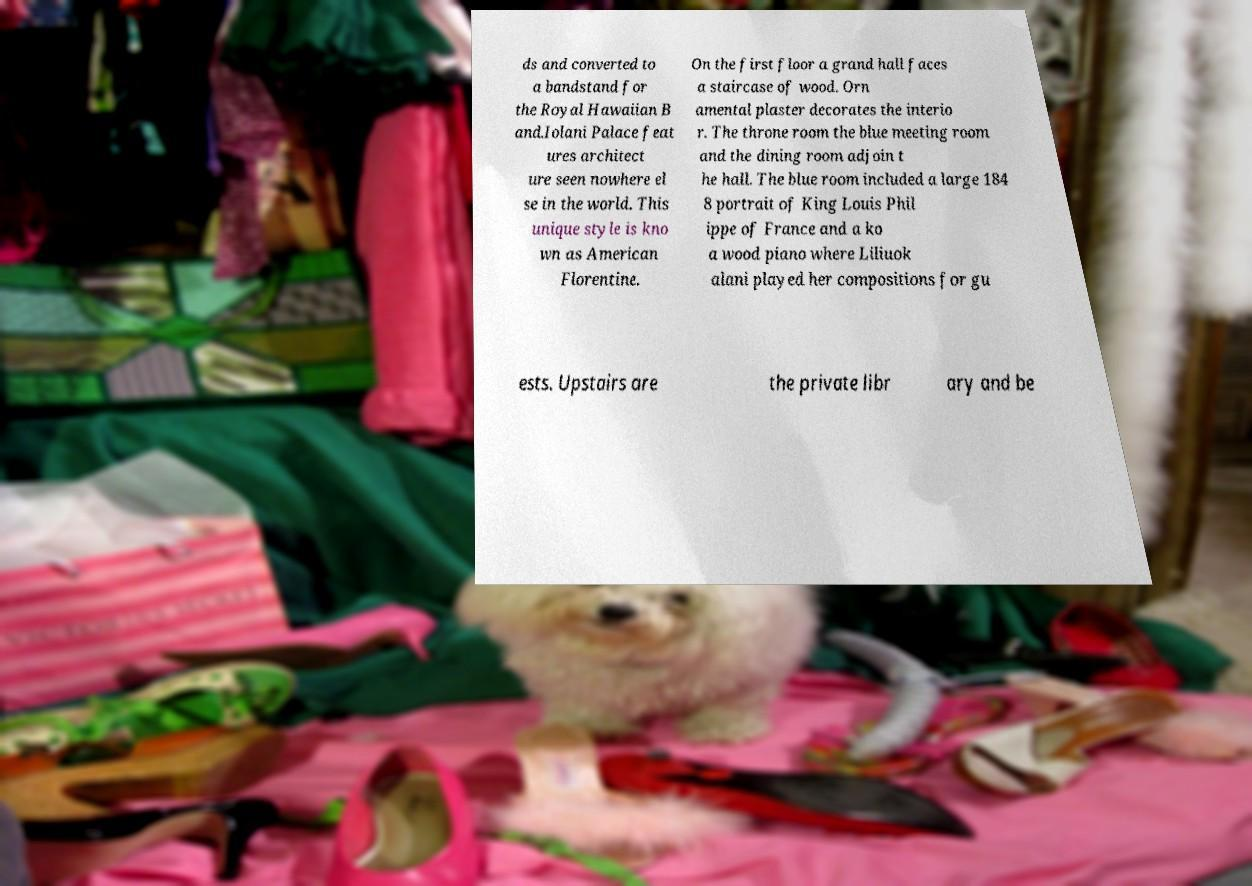Can you accurately transcribe the text from the provided image for me? ds and converted to a bandstand for the Royal Hawaiian B and.Iolani Palace feat ures architect ure seen nowhere el se in the world. This unique style is kno wn as American Florentine. On the first floor a grand hall faces a staircase of wood. Orn amental plaster decorates the interio r. The throne room the blue meeting room and the dining room adjoin t he hall. The blue room included a large 184 8 portrait of King Louis Phil ippe of France and a ko a wood piano where Liliuok alani played her compositions for gu ests. Upstairs are the private libr ary and be 